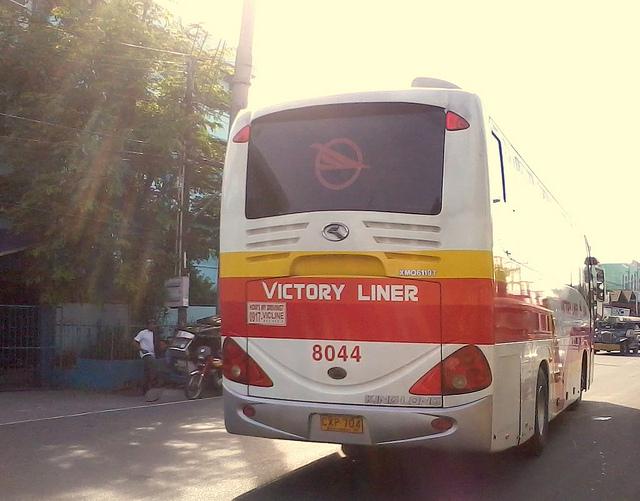Is there an advertisement on the back of the bus?
Be succinct. No. What are the numbers in red?
Short answer required. 8044. What color are the cars next to the bus?
Write a very short answer. Blue. What are the 4 red numbers in the front of the bus?
Concise answer only. 8044. What is the name of the bus company?
Write a very short answer. Victory liner. Is this the front or back of the vehicle?
Quick response, please. Back. What is written on the rear of the bus?
Quick response, please. Victory liner. What is the company name?
Be succinct. Victory liner. What is written on the truck?
Quick response, please. Victory liner. Where is the company located?
Write a very short answer. Canada. Are there any police officers in the street?
Concise answer only. No. 